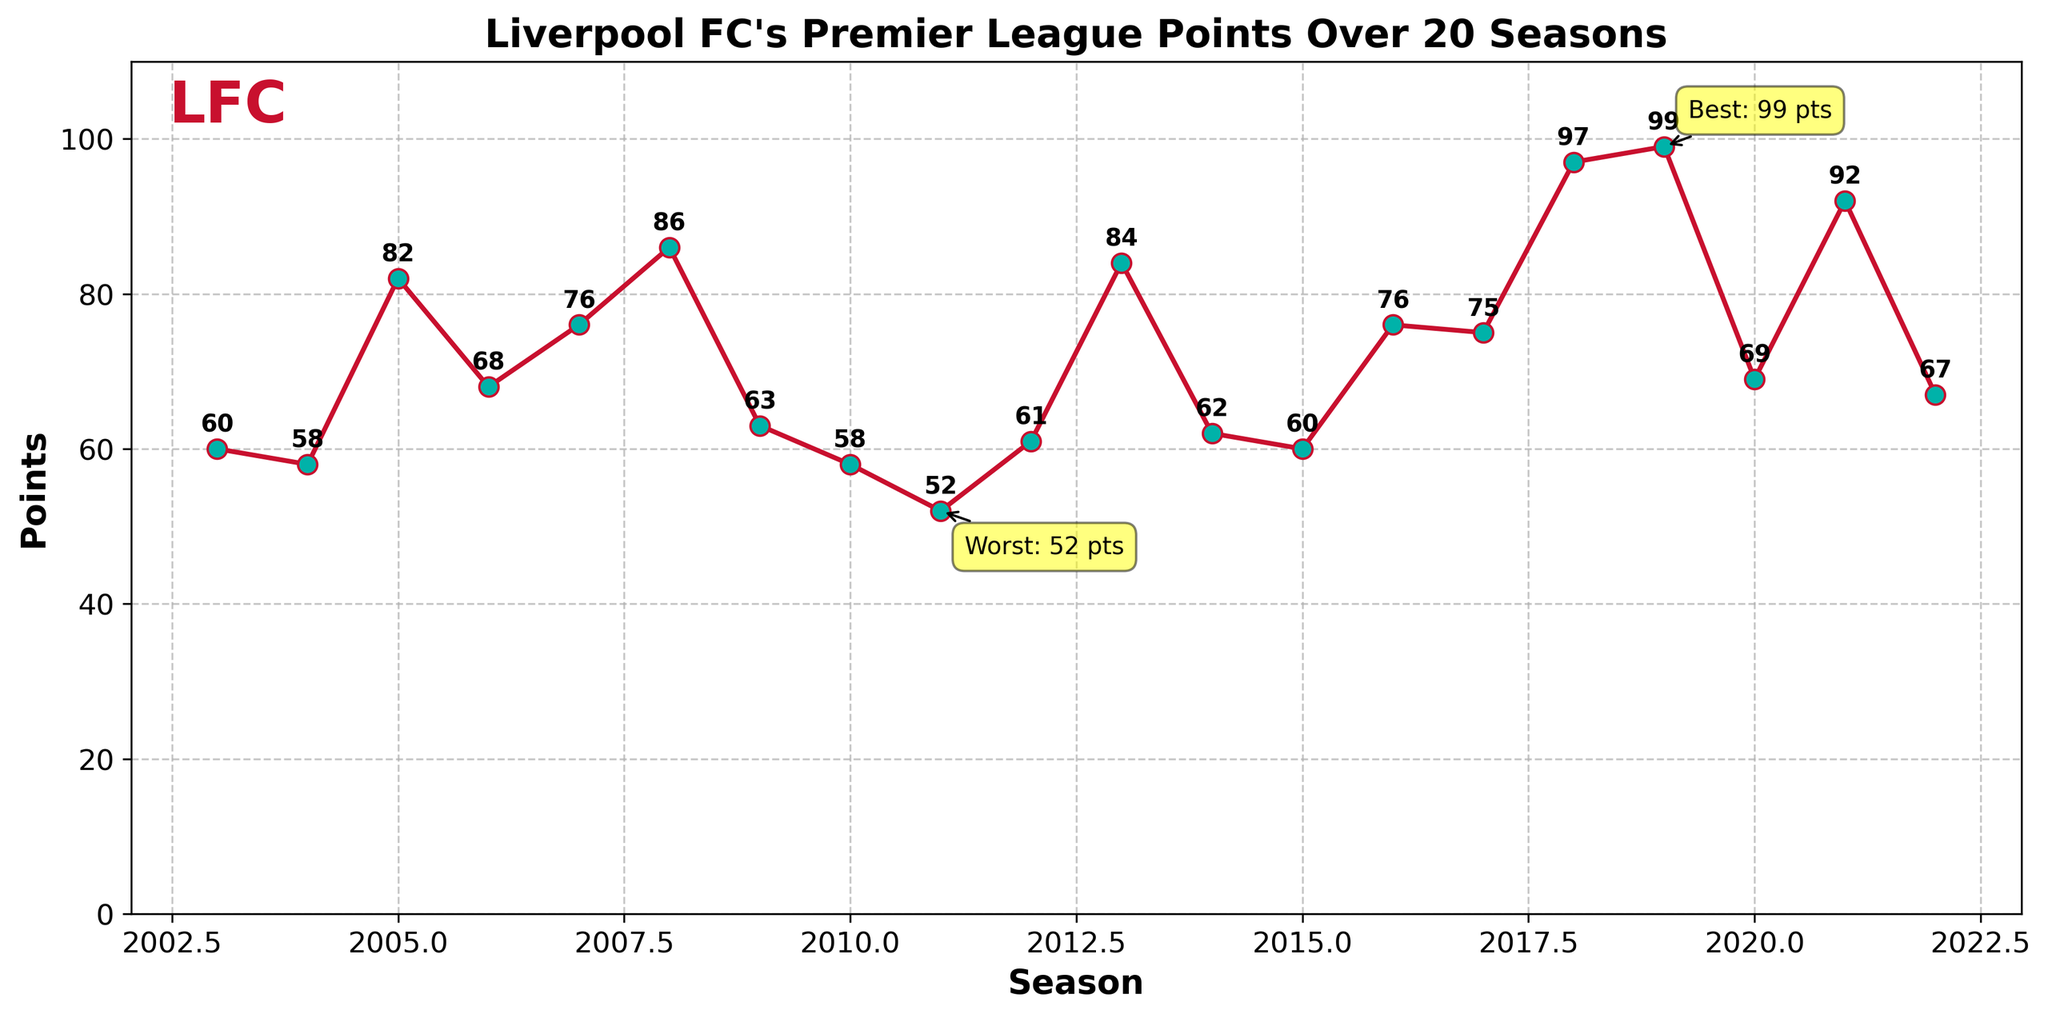What's the highest points tally Liverpool FC achieved in the past 20 seasons? Observing the plot, the highest data point on the y-axis represents the maximum points tally. The point with the highest value is 99 points in the 2019-20 season, indicated by both the label and the annotation.
Answer: 99 Which seasons did Liverpool FC achieve more than 90 points? To answer this, check the plot for seasons where the y-axis value is greater than 90. The labels indicating these points are in the 2018-19 (97 points) and 2021-22 (92 points) seasons.
Answer: 2018-19, 2021-22 What is the difference in points between the best and worst seasons? The plot shows the highest points as 99 (2019-20) and the lowest as 52 (2011-12). The difference is calculated as 99 - 52 = 47 points.
Answer: 47 In which season did Liverpool FC experience the largest drop in points compared to the previous season? To identify this, visually look for the steepest decline between consecutive points in the plot. The largest drop appears between 2008-09 (86 points) and 2009-10 (63 points), a difference of 86 - 63 = 23 points.
Answer: 2009-10 How many times did Liverpool FC finish a season with more than 75 points in the past 20 seasons? To find this, count the number of data points exceeding 75 on the y-axis. The seasons are 2005-06, 2007-08, 2008-09, 2013-14, 2016-17, 2018-19, 2019-20, and 2021-22, making a total of 8 times.
Answer: 8 What's the average points tally for Liverpool FC over the past 20 seasons? Calculate the average by summing all the points from the plot and dividing by the number of seasons. Sum: 60+58+82+68+76+86+63+58+52+61+84+62+60+76+75+97+99+69+92+67 = 1435. The average is 1435/20 = 71.75 points.
Answer: 71.75 During which period did Liverpool FC consistently achieve more than 75 points for the longest duration? Identify the longest continuous stretch where each season's points are above 75 by observing the plot. The three-season period from 2018-19 to 2021-22 shows consistent high performance with 97, 99, and 92 points respectively.
Answer: 2018-19 to 2021-22 Compared to the 2003-04 season, by how many points did Liverpool FC improve in the 2019-20 season? Subtract the points from the 2003-04 season (60 points) from the 2019-20 season (99 points). The calculation is 99 - 60 = 39 points.
Answer: 39 When did Liverpool FC see consecutive seasons with the same points tally? Observe the plot to find points from two consecutive seasons that are the same. Liverpool FC had 58 points both in the 2004-05 and 2010-11 seasons.
Answer: 2004-05 and 2010-11 What's the median points tally for Liverpool FC over the past 20 seasons? List the points in ascending order and find the middle value. Ordered points: 52, 58, 58, 60, 60, 61, 62, 63, 67, 68, 69, 75, 76, 76, 82, 84, 86, 92, 97, 99. The median is the average of the 10th and 11th values: (68+69)/2 = 68.5.
Answer: 68.5 